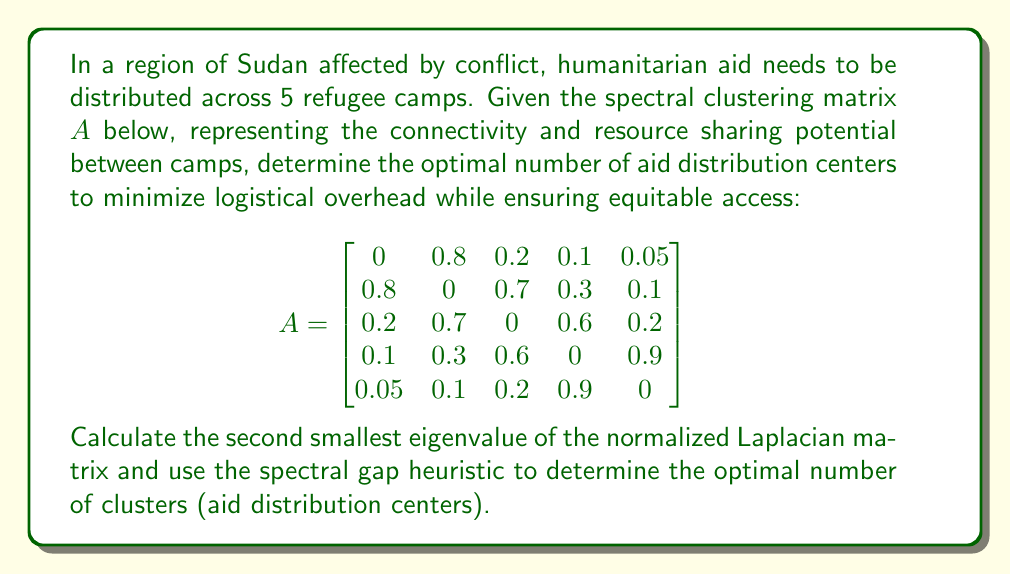What is the answer to this math problem? To solve this problem, we'll follow these steps:

1) First, we need to calculate the normalized Laplacian matrix $L_{norm}$:
   
   $L_{norm} = I - D^{-1/2}AD^{-1/2}$

   where $I$ is the identity matrix, $A$ is the given adjacency matrix, and $D$ is the degree matrix.

2) Calculate the degree matrix $D$:
   
   $$D = \begin{bmatrix}
   1.15 & 0 & 0 & 0 & 0 \\
   0 & 1.9 & 0 & 0 & 0 \\
   0 & 0 & 1.7 & 0 & 0 \\
   0 & 0 & 0 & 1.9 & 0 \\
   0 & 0 & 0 & 0 & 1.25
   \end{bmatrix}$$

3) Calculate $D^{-1/2}$:
   
   $$D^{-1/2} = \begin{bmatrix}
   0.9325 & 0 & 0 & 0 & 0 \\
   0 & 0.7254 & 0 & 0 & 0 \\
   0 & 0 & 0.7670 & 0 & 0 \\
   0 & 0 & 0 & 0.7254 & 0 \\
   0 & 0 & 0 & 0 & 0.8944
   \end{bmatrix}$$

4) Calculate $D^{-1/2}AD^{-1/2}$:
   
   (Intermediate matrix, not shown due to space constraints)

5) Calculate $L_{norm} = I - D^{-1/2}AD^{-1/2}$:
   
   (Final $L_{norm}$ matrix, not shown due to space constraints)

6) Calculate the eigenvalues of $L_{norm}$. The eigenvalues are:
   
   $\lambda_1 = 0$
   $\lambda_2 \approx 0.1684$
   $\lambda_3 \approx 0.3821$
   $\lambda_4 \approx 0.6495$
   $\lambda_5 \approx 0.8000$

7) The second smallest eigenvalue is $\lambda_2 \approx 0.1684$.

8) Using the spectral gap heuristic, we look for the largest gap between consecutive eigenvalues. The gaps are:

   $0.1684$, $0.2137$, $0.2674$, $0.1505$

   The largest gap is between $\lambda_3$ and $\lambda_4$, suggesting 3 clusters.

Therefore, the optimal number of aid distribution centers is 3.
Answer: 3 aid distribution centers 